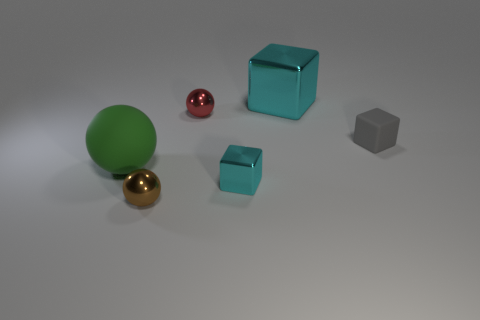Subtract all tiny balls. How many balls are left? 1 Add 1 cyan metallic objects. How many objects exist? 7 Subtract all small red shiny balls. Subtract all tiny metallic spheres. How many objects are left? 3 Add 2 red things. How many red things are left? 3 Add 4 matte blocks. How many matte blocks exist? 5 Subtract 0 green cylinders. How many objects are left? 6 Subtract all blue blocks. Subtract all green cylinders. How many blocks are left? 3 